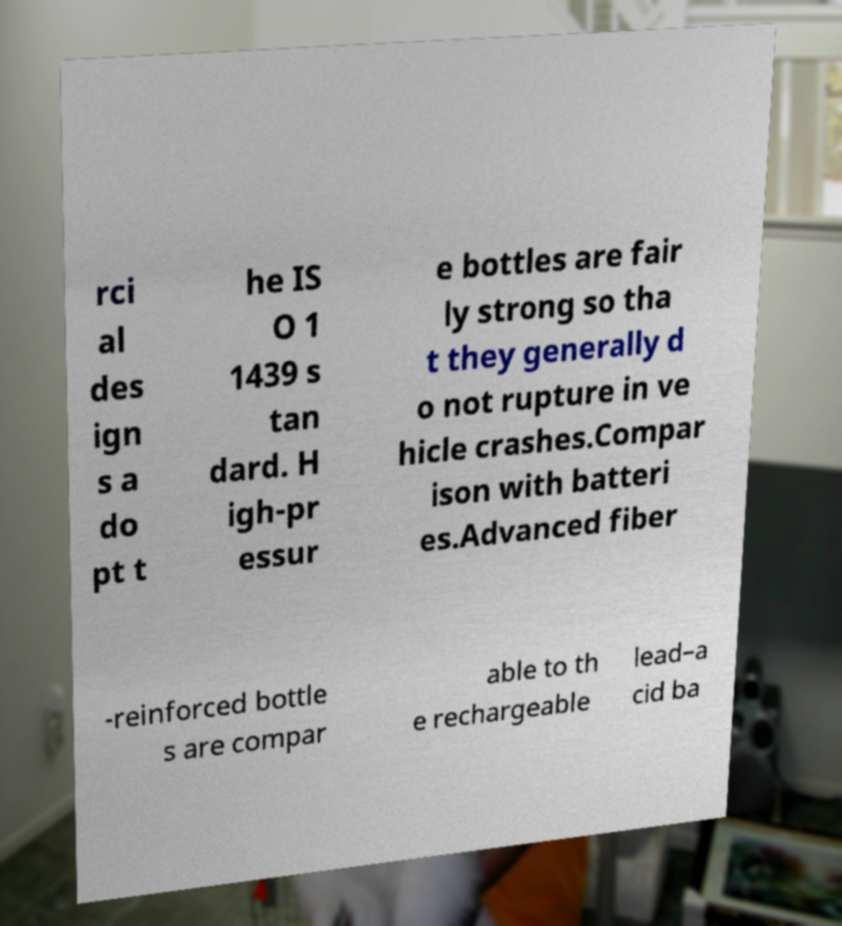Please read and relay the text visible in this image. What does it say? rci al des ign s a do pt t he IS O 1 1439 s tan dard. H igh-pr essur e bottles are fair ly strong so tha t they generally d o not rupture in ve hicle crashes.Compar ison with batteri es.Advanced fiber -reinforced bottle s are compar able to th e rechargeable lead–a cid ba 